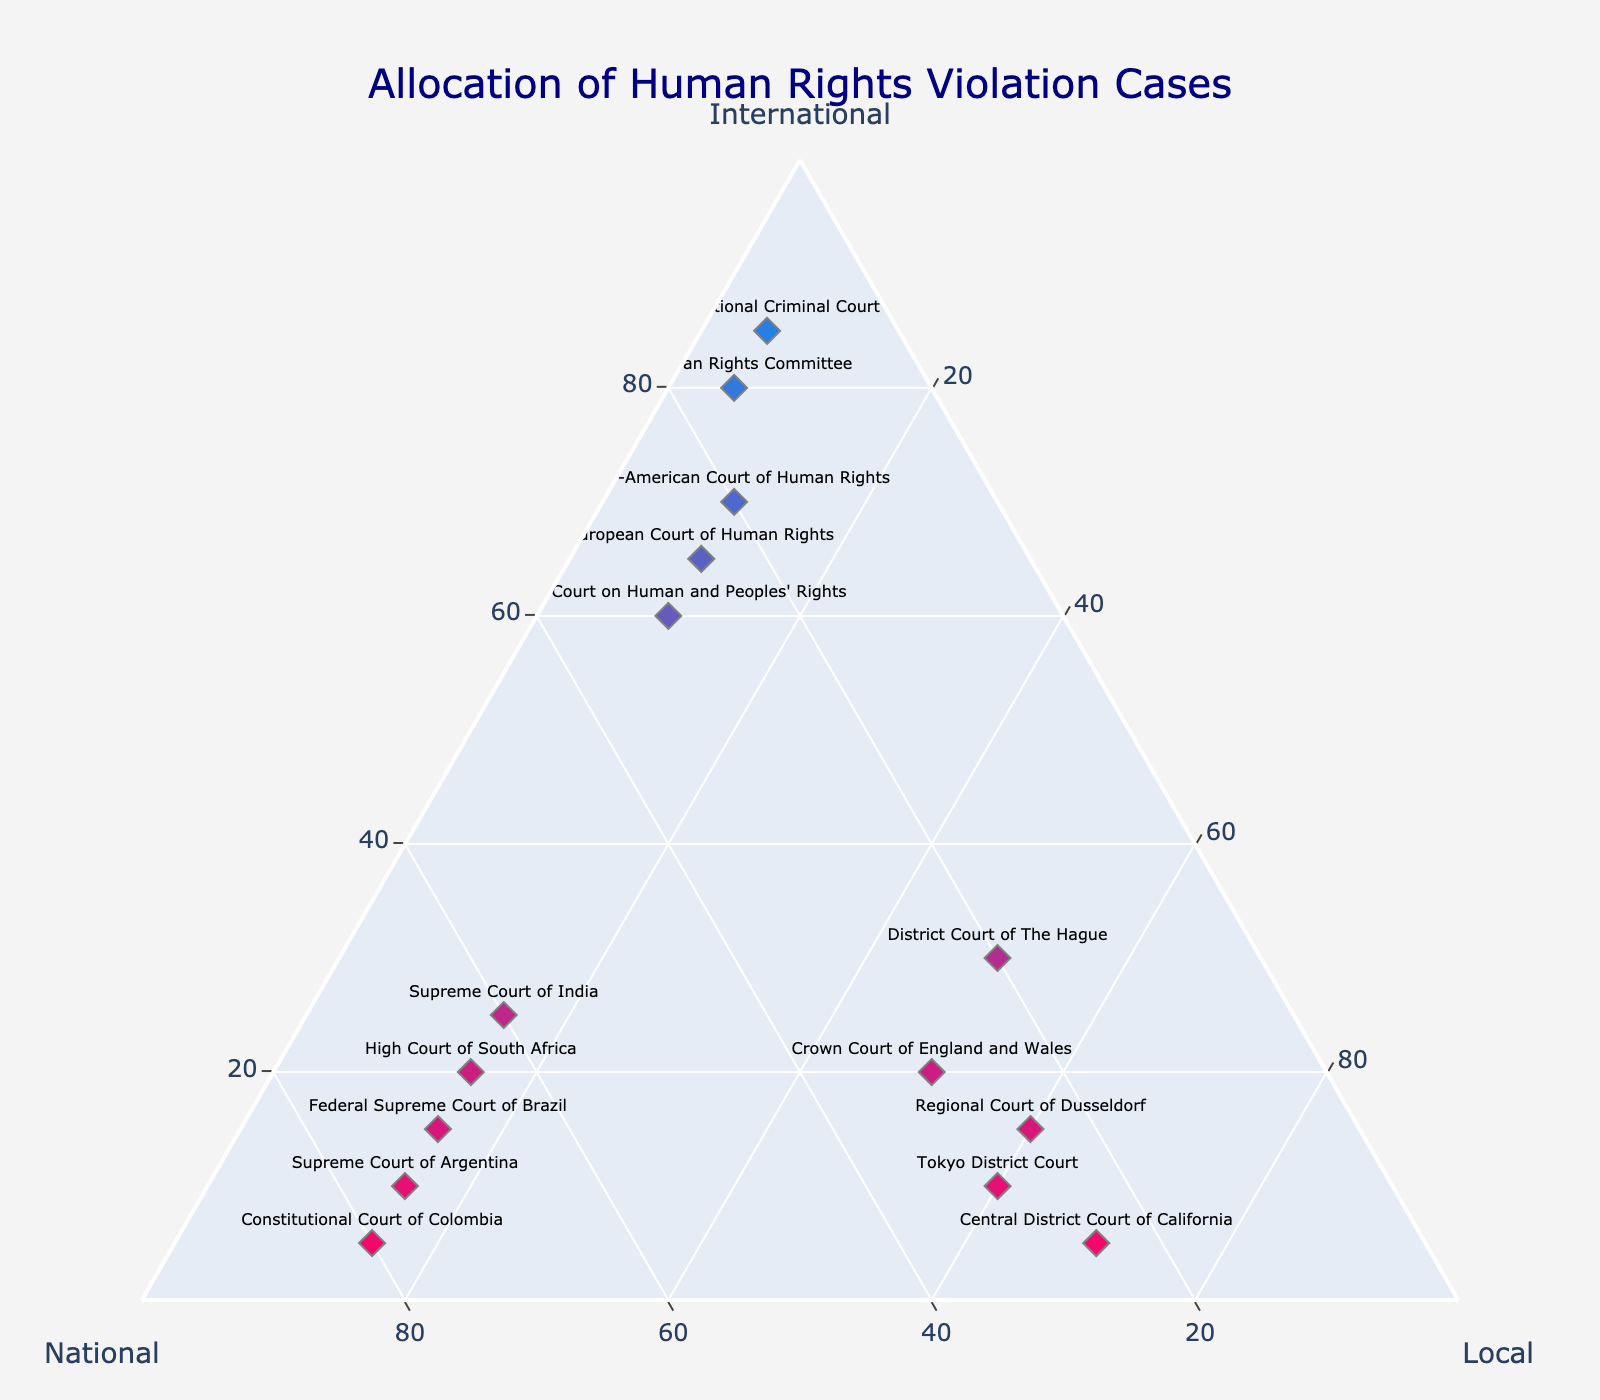What's the title of the figure? The title is written at the top center of the figure, in navy color and large size, making it easily readable.
Answer: Allocation of Human Rights Violation Cases How many courts allocate more than half of their cases to international courts? By examining the "International" axis and identifying the points where the value is greater than 50%, there are five such courts: Inter-American Court of Human Rights, European Court of Human Rights, African Court on Human and Peoples' Rights, UN Human Rights Committee, and International Criminal Court.
Answer: 5 What is the average percentage of cases handled by local courts? Adding up the 'Local' column for all courts: 10+10+10+5+5+15+15+15+15+15+50+70+60+60+50 = 415. There are 15 courts, so the average is 415/15 = 27.67.
Answer: 27.67 Which court has the highest allocation to national courts and what is that percentage? By examining the "National" axis, the Constitutional Court of Colombia has the highest value at 80%.
Answer: Constitutional Court of Colombia, 80% How does the Central District Court of California's local allocation compare to that of the Crown Court of England and Wales? The Central District Court of California has 70% local allocation while the Crown Court of England and Wales has 50%. Therefore, the Central District Court of California has a higher local allocation.
Answer: Central District Court of California has higher local allocation What is the combined percentage of cases handled internationally by both the Supreme Court of Argentina and the High Court of South Africa? Adding the international percentages of both courts: 10% (Supreme Court of Argentina) + 20% (High Court of South Africa) = 30%.
Answer: 30% Which court has the smallest percentage of cases handled locally and what is that percentage? By examining the "Local" axis, the UN Human Rights Committee and the International Criminal Court both have the lowest value at 5%.
Answer: UN Human Rights Committee and International Criminal Court, 5% How does the allocation of cases by the Supreme Court of India compare between national and local courts? The Supreme Court of India allocates 60% to national courts and 15% to local courts, indicating a significantly higher allocation to national courts.
Answer: National courts have a higher allocation Which court has equal percentage distribution between national and local courts? By examining the plot, no court has an equal percentage distribution between national and local courts.
Answer: None What is the total percentage of cases handled by the European Court of Human Rights across all three categories? Since the total sum of a point in a ternary plot is 100%, the European Court of Human Rights handles 65% internationally, 25% nationally, and 10% locally. Sum = 65+25+10 = 100%.
Answer: 100% 